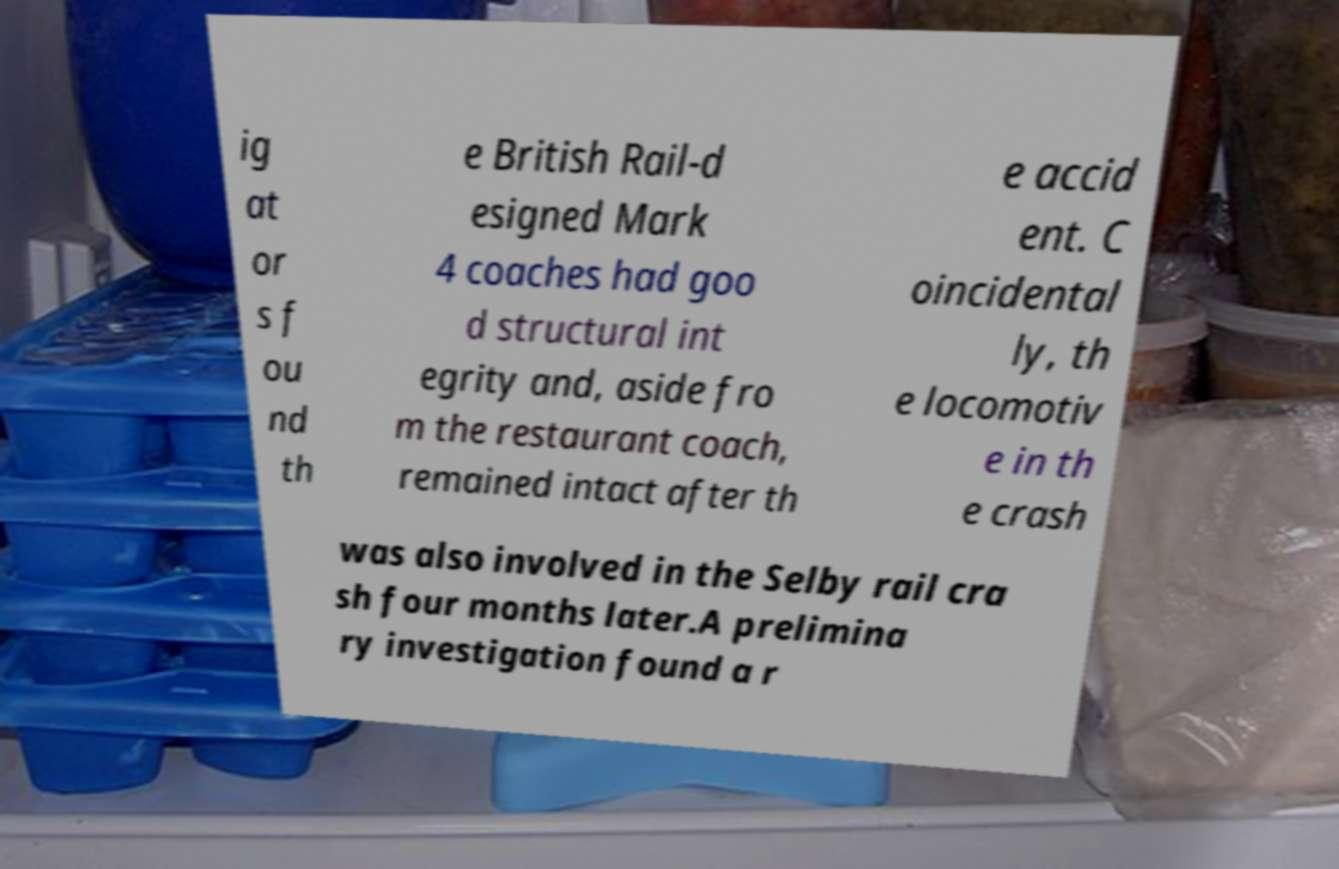I need the written content from this picture converted into text. Can you do that? ig at or s f ou nd th e British Rail-d esigned Mark 4 coaches had goo d structural int egrity and, aside fro m the restaurant coach, remained intact after th e accid ent. C oincidental ly, th e locomotiv e in th e crash was also involved in the Selby rail cra sh four months later.A prelimina ry investigation found a r 